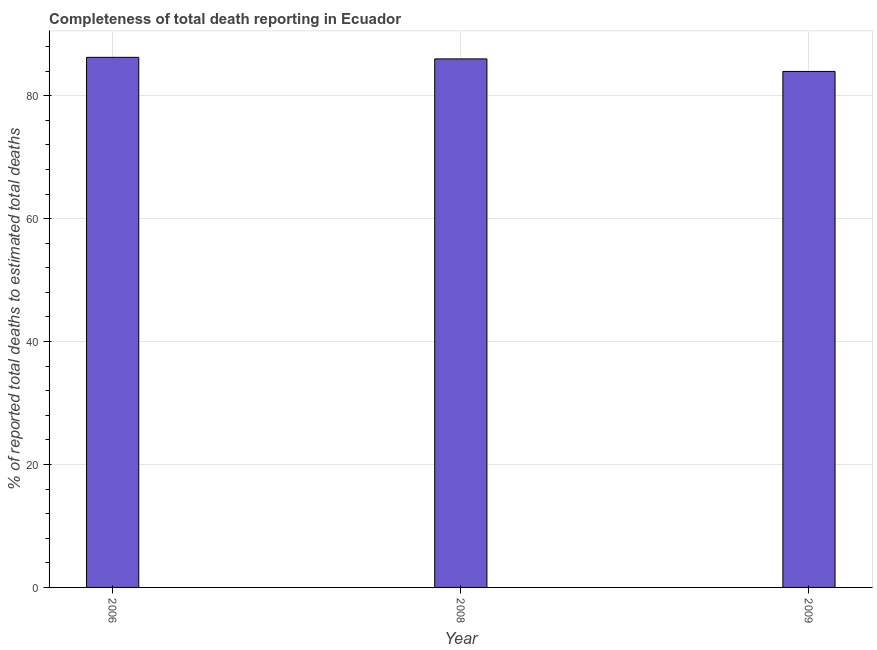Does the graph contain any zero values?
Keep it short and to the point. No. Does the graph contain grids?
Ensure brevity in your answer.  Yes. What is the title of the graph?
Provide a short and direct response. Completeness of total death reporting in Ecuador. What is the label or title of the Y-axis?
Provide a succinct answer. % of reported total deaths to estimated total deaths. What is the completeness of total death reports in 2008?
Your answer should be compact. 85.99. Across all years, what is the maximum completeness of total death reports?
Your response must be concise. 86.24. Across all years, what is the minimum completeness of total death reports?
Your answer should be very brief. 83.95. What is the sum of the completeness of total death reports?
Your answer should be very brief. 256.18. What is the difference between the completeness of total death reports in 2006 and 2008?
Provide a succinct answer. 0.26. What is the average completeness of total death reports per year?
Provide a succinct answer. 85.39. What is the median completeness of total death reports?
Make the answer very short. 85.99. Do a majority of the years between 2009 and 2006 (inclusive) have completeness of total death reports greater than 48 %?
Make the answer very short. Yes. Is the completeness of total death reports in 2006 less than that in 2009?
Your answer should be compact. No. What is the difference between the highest and the second highest completeness of total death reports?
Offer a terse response. 0.26. What is the difference between the highest and the lowest completeness of total death reports?
Offer a very short reply. 2.29. Are all the bars in the graph horizontal?
Provide a succinct answer. No. How many years are there in the graph?
Ensure brevity in your answer.  3. What is the % of reported total deaths to estimated total deaths in 2006?
Your answer should be very brief. 86.24. What is the % of reported total deaths to estimated total deaths in 2008?
Offer a terse response. 85.99. What is the % of reported total deaths to estimated total deaths of 2009?
Your answer should be very brief. 83.95. What is the difference between the % of reported total deaths to estimated total deaths in 2006 and 2008?
Ensure brevity in your answer.  0.26. What is the difference between the % of reported total deaths to estimated total deaths in 2006 and 2009?
Ensure brevity in your answer.  2.29. What is the difference between the % of reported total deaths to estimated total deaths in 2008 and 2009?
Your answer should be very brief. 2.04. What is the ratio of the % of reported total deaths to estimated total deaths in 2006 to that in 2009?
Provide a succinct answer. 1.03. What is the ratio of the % of reported total deaths to estimated total deaths in 2008 to that in 2009?
Keep it short and to the point. 1.02. 